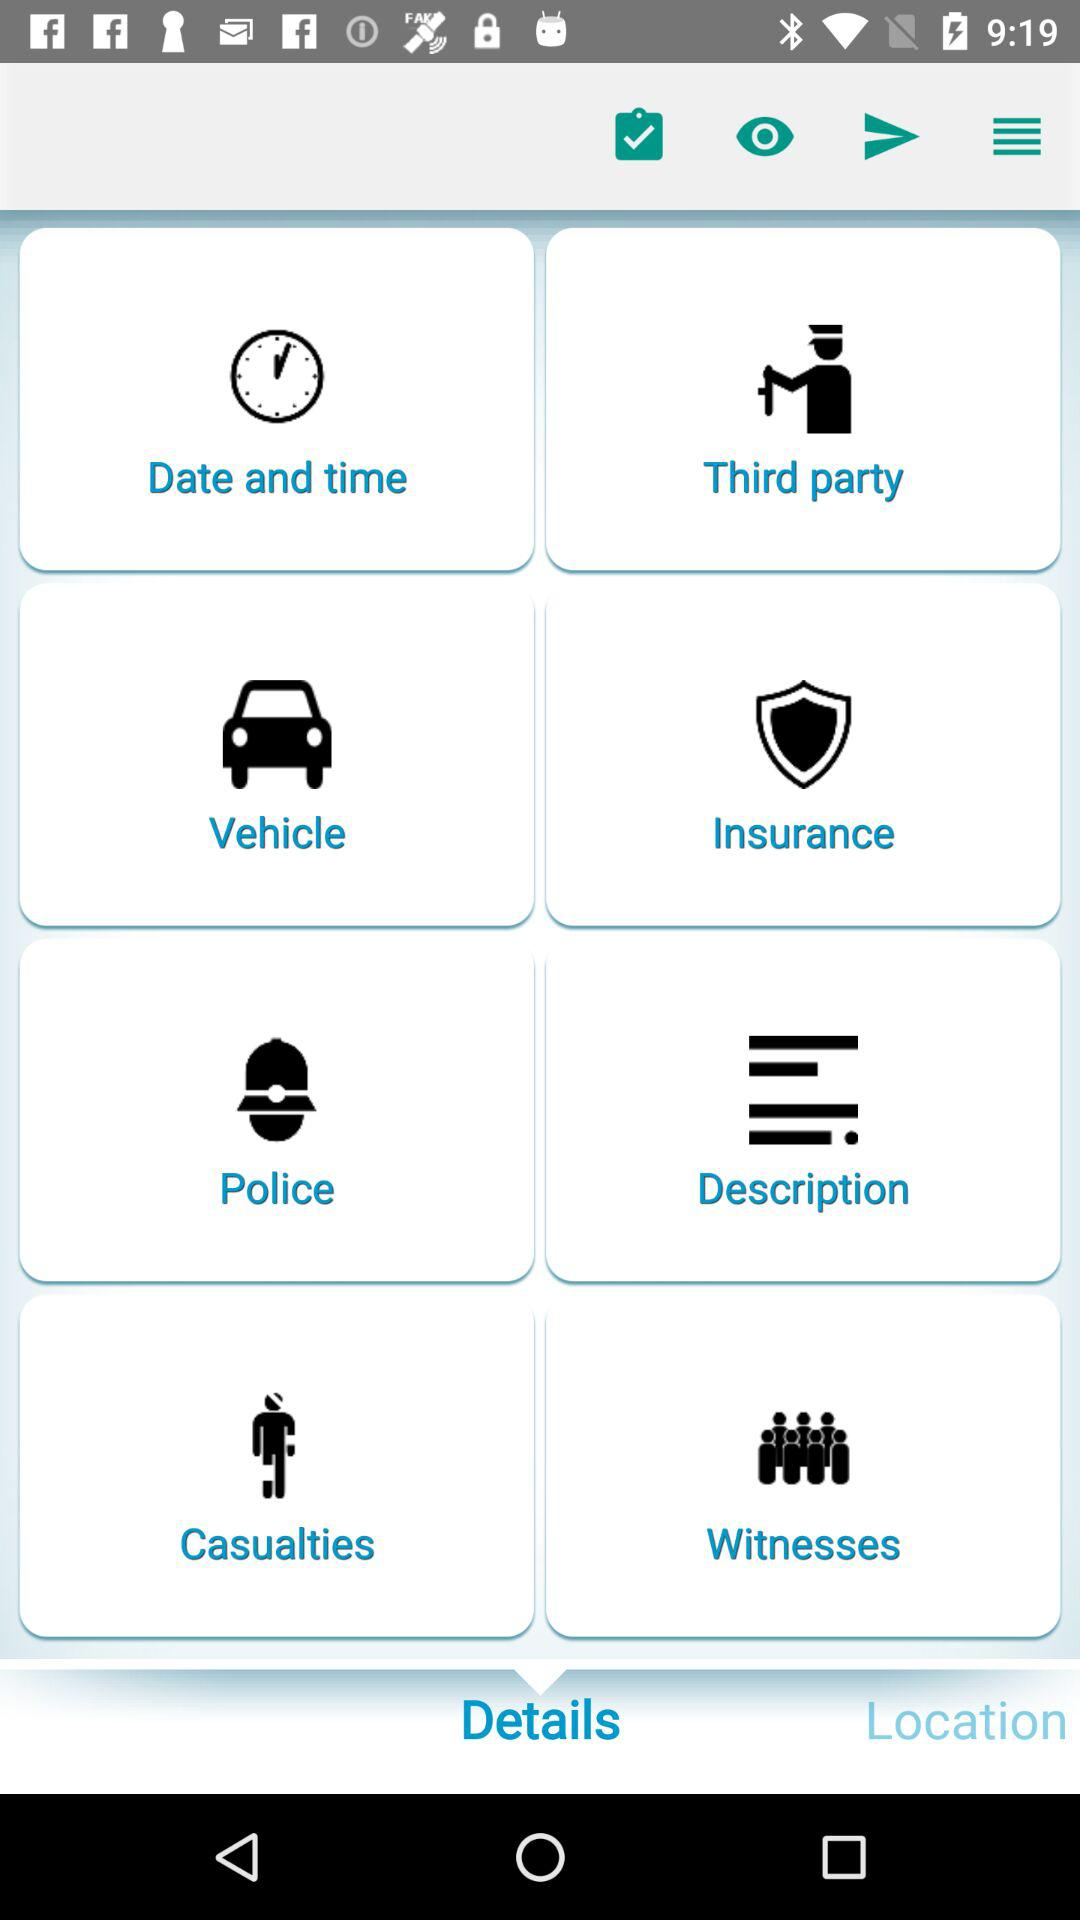Which tab has been selected? The selected tab is "Details". 